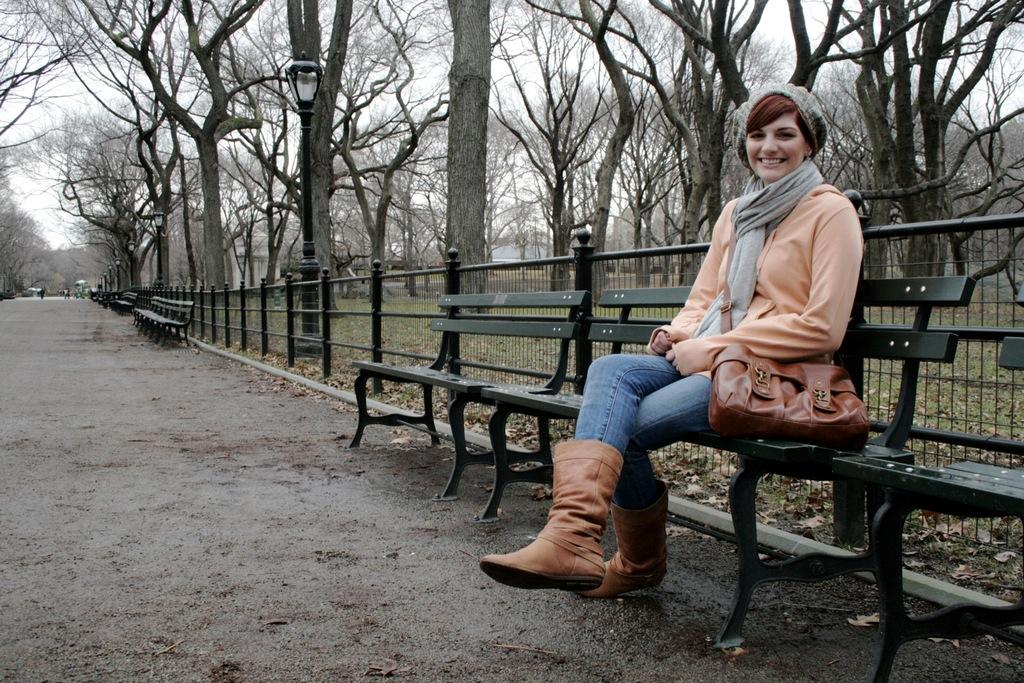What is the woman in the image doing? The woman is sitting on a bench in the image. Where is the bench located in the image? The bench is in the right corner of the image. What can be seen behind the woman? There are trees and a fence behind the woman. How many fish are swimming in the honey behind the woman in the image? There are no fish or honey present in the image; it only features a woman sitting on a bench, trees, and a fence. 